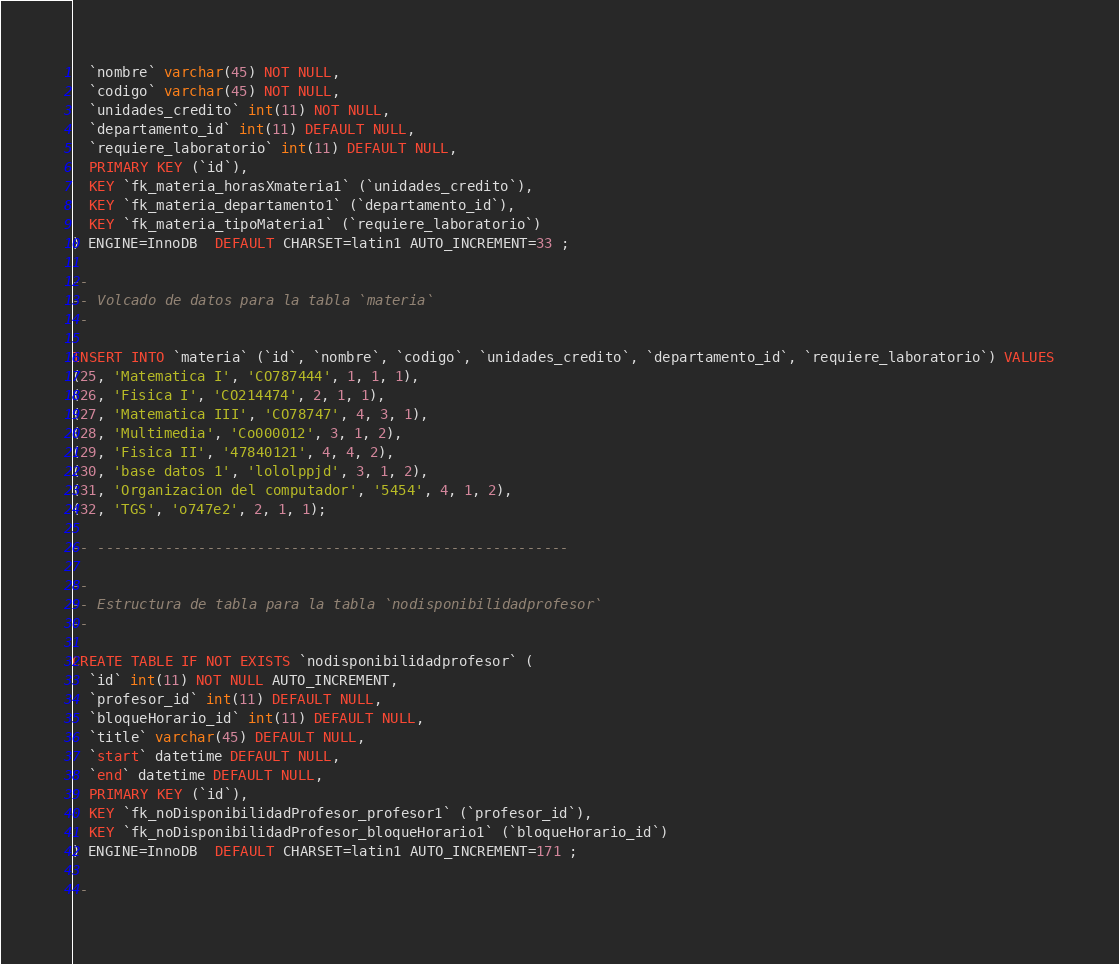<code> <loc_0><loc_0><loc_500><loc_500><_SQL_>  `nombre` varchar(45) NOT NULL,
  `codigo` varchar(45) NOT NULL,
  `unidades_credito` int(11) NOT NULL,
  `departamento_id` int(11) DEFAULT NULL,
  `requiere_laboratorio` int(11) DEFAULT NULL,
  PRIMARY KEY (`id`),
  KEY `fk_materia_horasXmateria1` (`unidades_credito`),
  KEY `fk_materia_departamento1` (`departamento_id`),
  KEY `fk_materia_tipoMateria1` (`requiere_laboratorio`)
) ENGINE=InnoDB  DEFAULT CHARSET=latin1 AUTO_INCREMENT=33 ;

--
-- Volcado de datos para la tabla `materia`
--

INSERT INTO `materia` (`id`, `nombre`, `codigo`, `unidades_credito`, `departamento_id`, `requiere_laboratorio`) VALUES
(25, 'Matematica I', 'CO787444', 1, 1, 1),
(26, 'Fisica I', 'CO214474', 2, 1, 1),
(27, 'Matematica III', 'CO78747', 4, 3, 1),
(28, 'Multimedia', 'Co000012', 3, 1, 2),
(29, 'Fisica II', '47840121', 4, 4, 2),
(30, 'base datos 1', 'lololppjd', 3, 1, 2),
(31, 'Organizacion del computador', '5454', 4, 1, 2),
(32, 'TGS', 'o747e2', 2, 1, 1);

-- --------------------------------------------------------

--
-- Estructura de tabla para la tabla `nodisponibilidadprofesor`
--

CREATE TABLE IF NOT EXISTS `nodisponibilidadprofesor` (
  `id` int(11) NOT NULL AUTO_INCREMENT,
  `profesor_id` int(11) DEFAULT NULL,
  `bloqueHorario_id` int(11) DEFAULT NULL,
  `title` varchar(45) DEFAULT NULL,
  `start` datetime DEFAULT NULL,
  `end` datetime DEFAULT NULL,
  PRIMARY KEY (`id`),
  KEY `fk_noDisponibilidadProfesor_profesor1` (`profesor_id`),
  KEY `fk_noDisponibilidadProfesor_bloqueHorario1` (`bloqueHorario_id`)
) ENGINE=InnoDB  DEFAULT CHARSET=latin1 AUTO_INCREMENT=171 ;

--</code> 